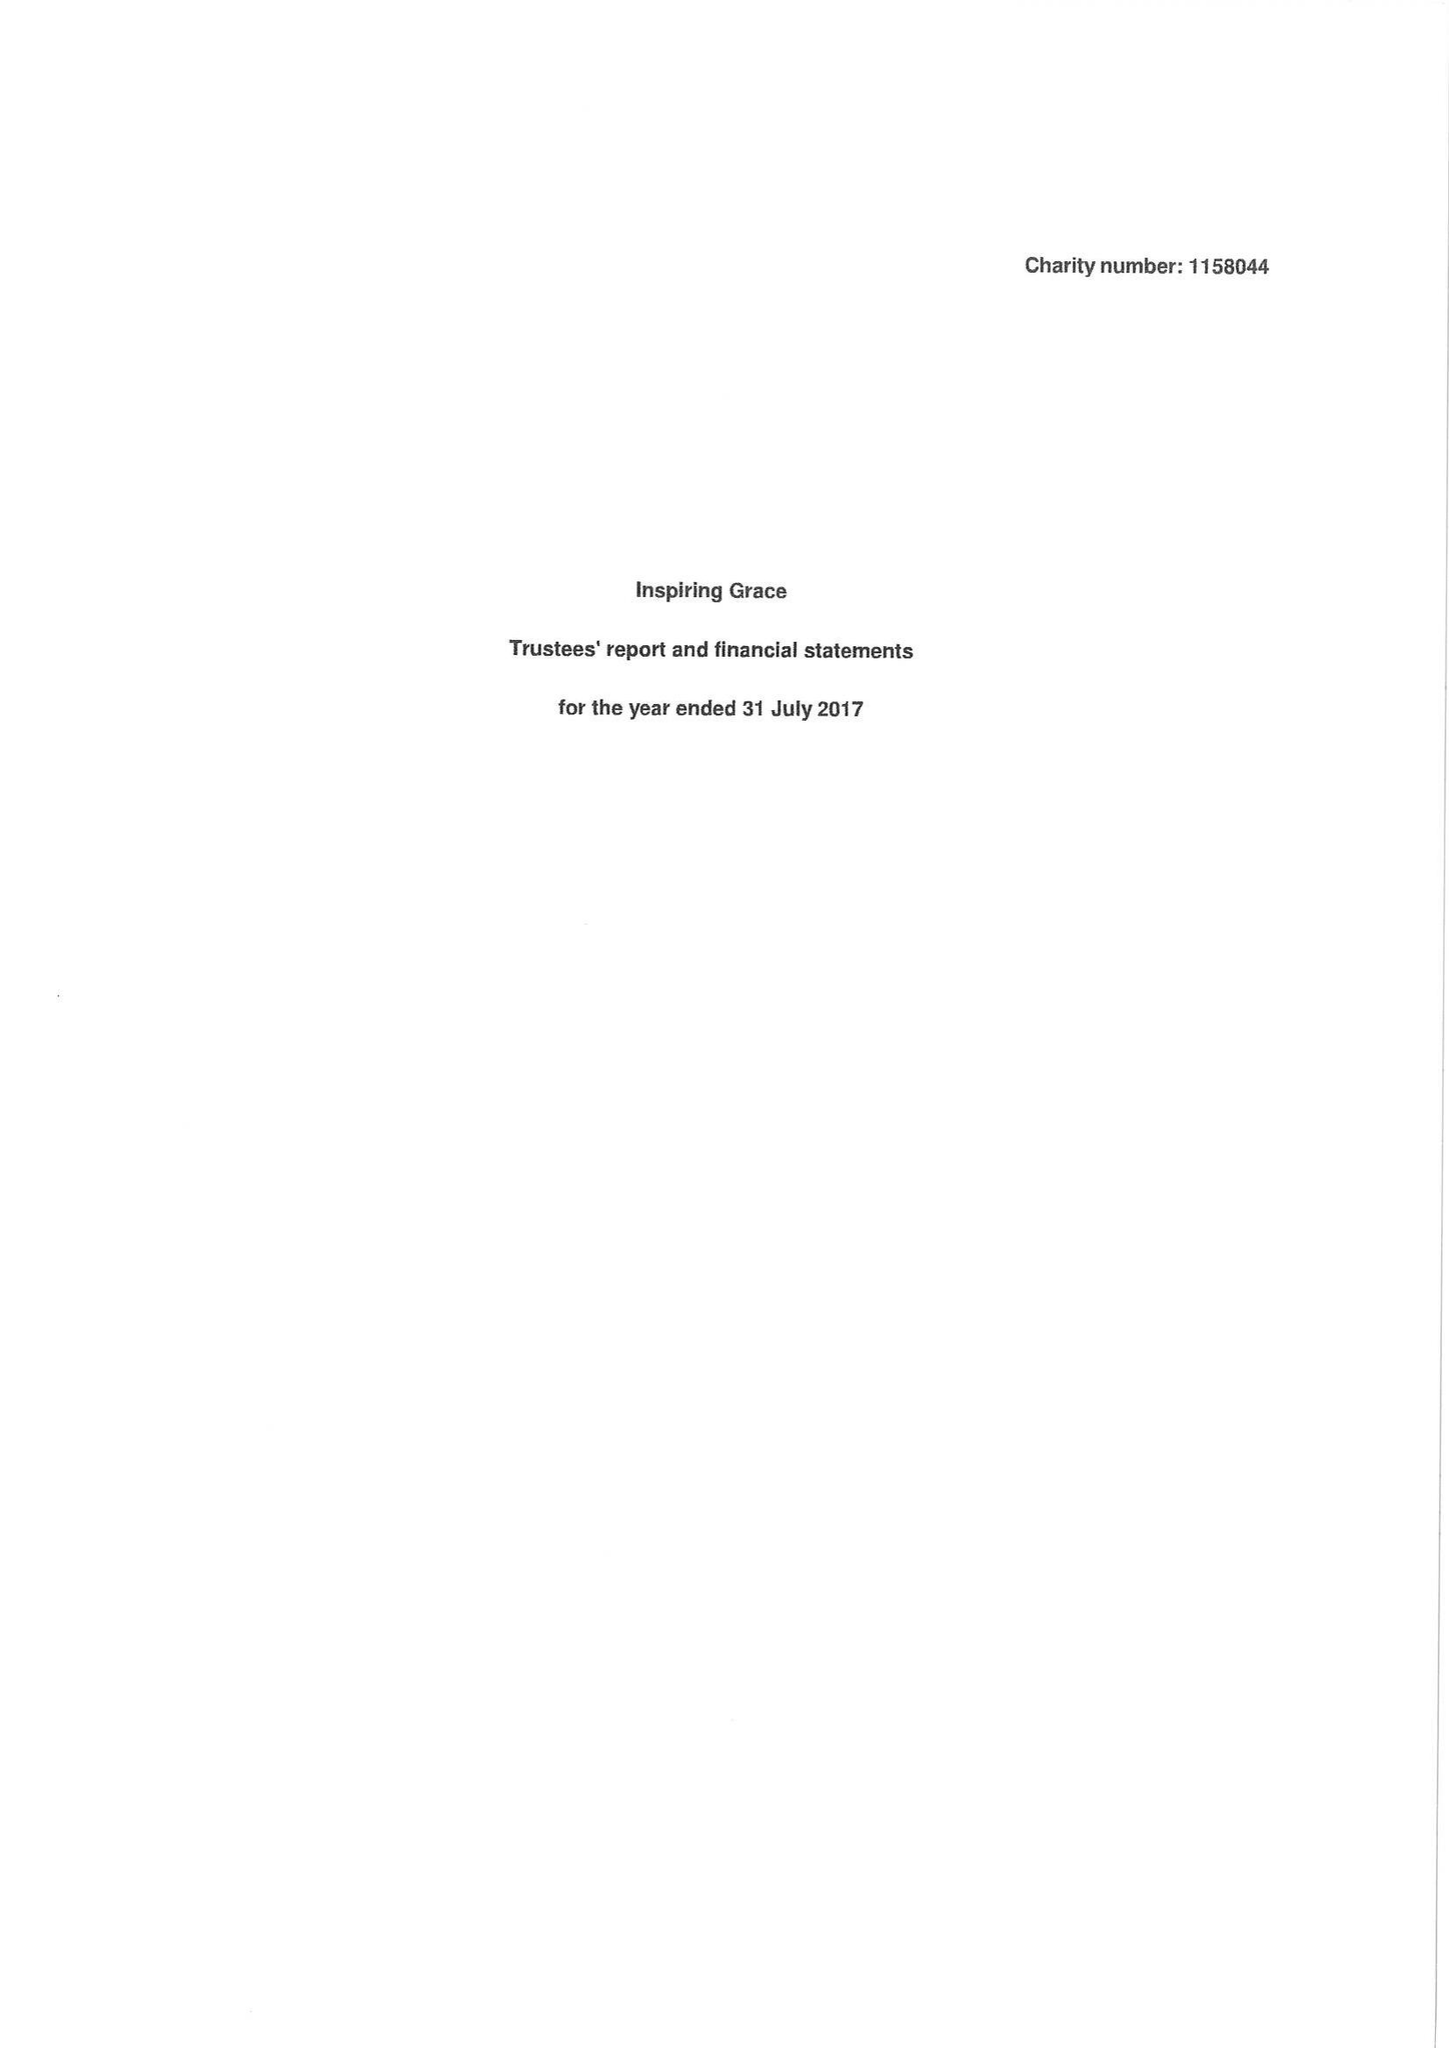What is the value for the charity_name?
Answer the question using a single word or phrase. Inspiring Grace 